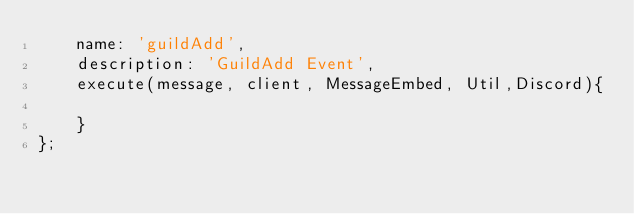<code> <loc_0><loc_0><loc_500><loc_500><_JavaScript_>    name: 'guildAdd',  
    description: 'GuildAdd Event',
    execute(message, client, MessageEmbed, Util,Discord){
        
    }
};
</code> 